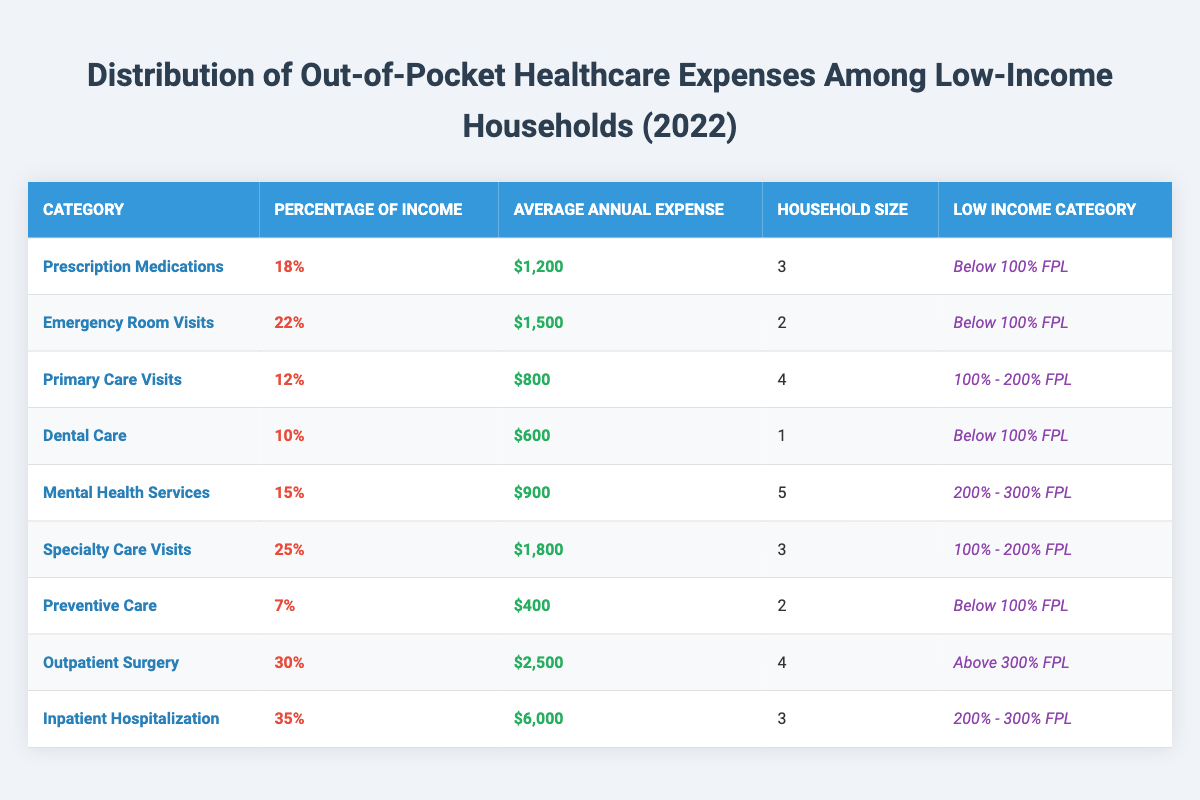What is the average annual expense for Prescription Medications? The average annual expense for Prescription Medications is directly listed in the table as $1,200.
Answer: $1,200 Which healthcare category has the highest percentage of income spent? In the table, Outpatient Surgery has the highest percentage of income spent at 30%.
Answer: 30% How much does a low-income household below 100% FPL spend on Emergency Room Visits? The table specifies that a household below 100% FPL spends an average of $1,500 on Emergency Room Visits.
Answer: $1,500 What is the total average annual expense for the categories listed under "Below 100% FPL"? Adding the average annual expenses for categories under "Below 100% FPL" gives: $1,200 (Prescription Medications) + $1,500 (Emergency Room Visits) + $600 (Dental Care) + $400 (Preventive Care) = $3,700.
Answer: $3,700 Is the average annual expense for Mental Health Services higher than $1,000? The table shows that the average annual expense for Mental Health Services is $900, which is less than $1,000.
Answer: No What percentage of income do households in the 200% - 300% FPL range spend on Inpatient Hospitalization? According to the table, households in the 200% - 300% FPL range spend 35% of their income on Inpatient Hospitalization.
Answer: 35% Which healthcare service has the lowest average annual expense, and how much is it? The table indicates that Preventive Care has the lowest average annual expense at $400.
Answer: $400 If a household in the 100% - 200% FPL range has three members, what is their average annual expense for Specialty Care Visits? The table shows that Specialty Care Visits cost an average of $1,800 for households with a size of 3 in the 100% - 200% FPL range.
Answer: $1,800 How many members are in the household that spends the highest percentage of their income on healthcare? The household that spends the highest percentage of their income, 35% on Inpatient Hospitalization, has 3 members.
Answer: 3 Calculate the average percentage of income spent on healthcare for households below 100% FPL. The percentages for households below 100% FPL are: 18% (Prescription Medications), 22% (Emergency Room Visits), 10% (Dental Care), and 7% (Preventive Care). The average is (18 + 22 + 10 + 7) / 4 = 57 / 4 = 14.25%.
Answer: 14.25% 